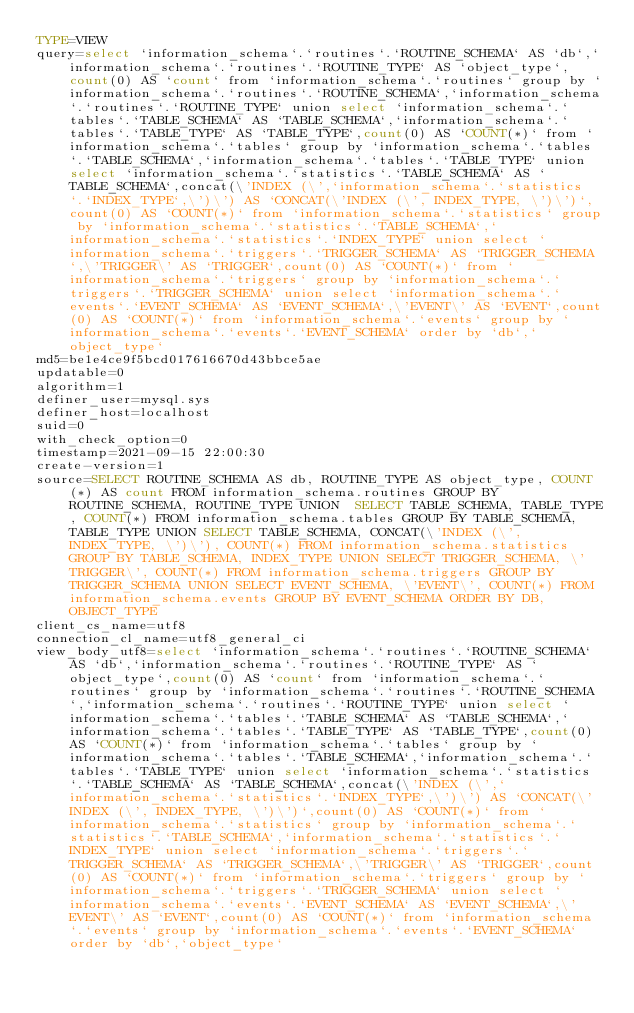Convert code to text. <code><loc_0><loc_0><loc_500><loc_500><_VisualBasic_>TYPE=VIEW
query=select `information_schema`.`routines`.`ROUTINE_SCHEMA` AS `db`,`information_schema`.`routines`.`ROUTINE_TYPE` AS `object_type`,count(0) AS `count` from `information_schema`.`routines` group by `information_schema`.`routines`.`ROUTINE_SCHEMA`,`information_schema`.`routines`.`ROUTINE_TYPE` union select `information_schema`.`tables`.`TABLE_SCHEMA` AS `TABLE_SCHEMA`,`information_schema`.`tables`.`TABLE_TYPE` AS `TABLE_TYPE`,count(0) AS `COUNT(*)` from `information_schema`.`tables` group by `information_schema`.`tables`.`TABLE_SCHEMA`,`information_schema`.`tables`.`TABLE_TYPE` union select `information_schema`.`statistics`.`TABLE_SCHEMA` AS `TABLE_SCHEMA`,concat(\'INDEX (\',`information_schema`.`statistics`.`INDEX_TYPE`,\')\') AS `CONCAT(\'INDEX (\', INDEX_TYPE, \')\')`,count(0) AS `COUNT(*)` from `information_schema`.`statistics` group by `information_schema`.`statistics`.`TABLE_SCHEMA`,`information_schema`.`statistics`.`INDEX_TYPE` union select `information_schema`.`triggers`.`TRIGGER_SCHEMA` AS `TRIGGER_SCHEMA`,\'TRIGGER\' AS `TRIGGER`,count(0) AS `COUNT(*)` from `information_schema`.`triggers` group by `information_schema`.`triggers`.`TRIGGER_SCHEMA` union select `information_schema`.`events`.`EVENT_SCHEMA` AS `EVENT_SCHEMA`,\'EVENT\' AS `EVENT`,count(0) AS `COUNT(*)` from `information_schema`.`events` group by `information_schema`.`events`.`EVENT_SCHEMA` order by `db`,`object_type`
md5=be1e4ce9f5bcd017616670d43bbce5ae
updatable=0
algorithm=1
definer_user=mysql.sys
definer_host=localhost
suid=0
with_check_option=0
timestamp=2021-09-15 22:00:30
create-version=1
source=SELECT ROUTINE_SCHEMA AS db, ROUTINE_TYPE AS object_type, COUNT(*) AS count FROM information_schema.routines GROUP BY ROUTINE_SCHEMA, ROUTINE_TYPE UNION  SELECT TABLE_SCHEMA, TABLE_TYPE, COUNT(*) FROM information_schema.tables GROUP BY TABLE_SCHEMA, TABLE_TYPE UNION SELECT TABLE_SCHEMA, CONCAT(\'INDEX (\', INDEX_TYPE, \')\'), COUNT(*) FROM information_schema.statistics GROUP BY TABLE_SCHEMA, INDEX_TYPE UNION SELECT TRIGGER_SCHEMA, \'TRIGGER\', COUNT(*) FROM information_schema.triggers GROUP BY TRIGGER_SCHEMA UNION SELECT EVENT_SCHEMA, \'EVENT\', COUNT(*) FROM information_schema.events GROUP BY EVENT_SCHEMA ORDER BY DB, OBJECT_TYPE
client_cs_name=utf8
connection_cl_name=utf8_general_ci
view_body_utf8=select `information_schema`.`routines`.`ROUTINE_SCHEMA` AS `db`,`information_schema`.`routines`.`ROUTINE_TYPE` AS `object_type`,count(0) AS `count` from `information_schema`.`routines` group by `information_schema`.`routines`.`ROUTINE_SCHEMA`,`information_schema`.`routines`.`ROUTINE_TYPE` union select `information_schema`.`tables`.`TABLE_SCHEMA` AS `TABLE_SCHEMA`,`information_schema`.`tables`.`TABLE_TYPE` AS `TABLE_TYPE`,count(0) AS `COUNT(*)` from `information_schema`.`tables` group by `information_schema`.`tables`.`TABLE_SCHEMA`,`information_schema`.`tables`.`TABLE_TYPE` union select `information_schema`.`statistics`.`TABLE_SCHEMA` AS `TABLE_SCHEMA`,concat(\'INDEX (\',`information_schema`.`statistics`.`INDEX_TYPE`,\')\') AS `CONCAT(\'INDEX (\', INDEX_TYPE, \')\')`,count(0) AS `COUNT(*)` from `information_schema`.`statistics` group by `information_schema`.`statistics`.`TABLE_SCHEMA`,`information_schema`.`statistics`.`INDEX_TYPE` union select `information_schema`.`triggers`.`TRIGGER_SCHEMA` AS `TRIGGER_SCHEMA`,\'TRIGGER\' AS `TRIGGER`,count(0) AS `COUNT(*)` from `information_schema`.`triggers` group by `information_schema`.`triggers`.`TRIGGER_SCHEMA` union select `information_schema`.`events`.`EVENT_SCHEMA` AS `EVENT_SCHEMA`,\'EVENT\' AS `EVENT`,count(0) AS `COUNT(*)` from `information_schema`.`events` group by `information_schema`.`events`.`EVENT_SCHEMA` order by `db`,`object_type`
</code> 